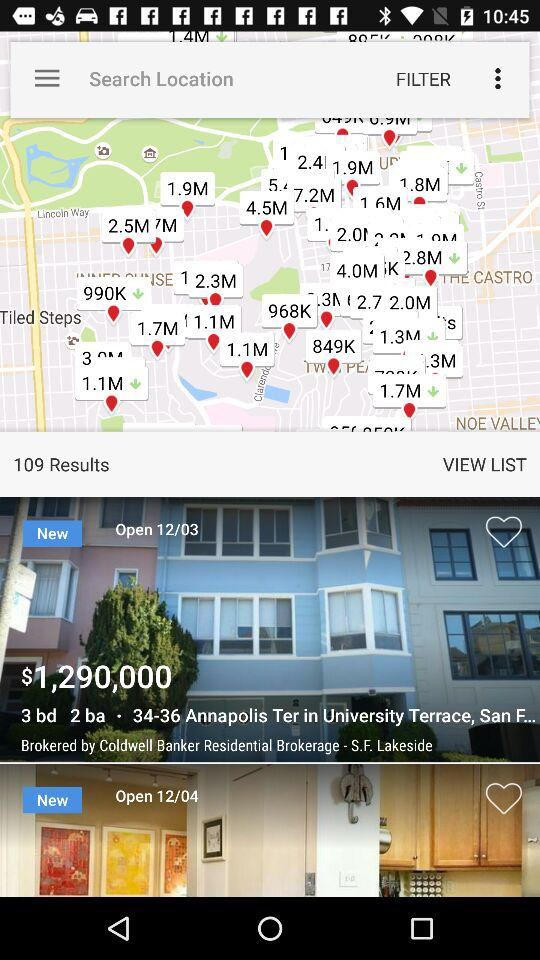When is the University of Annapolis Ter open?
When the provided information is insufficient, respond with <no answer>. <no answer> 